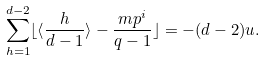Convert formula to latex. <formula><loc_0><loc_0><loc_500><loc_500>\sum _ { h = 1 } ^ { d - 2 } \lfloor \langle \frac { h } { d - 1 } \rangle - \frac { m p ^ { i } } { q - 1 } \rfloor = - ( d - 2 ) u .</formula> 